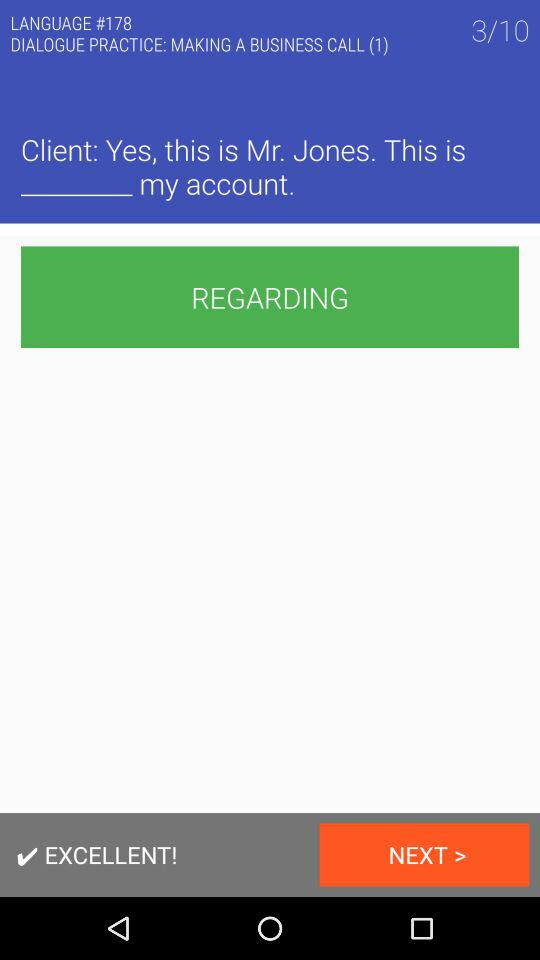On which number of slides are we? You are on slide number 3. 